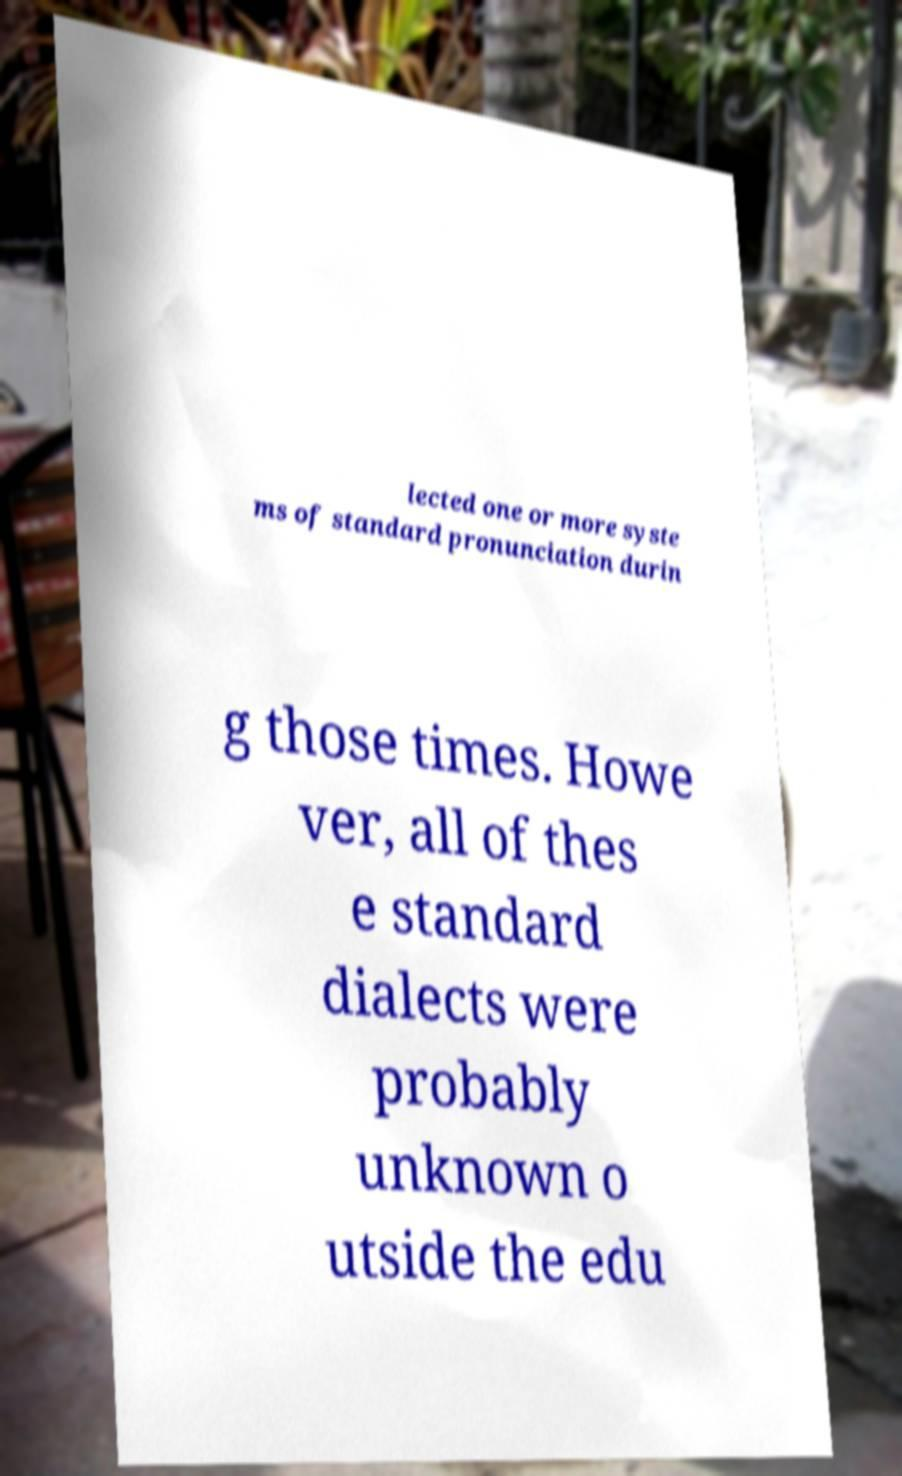Please identify and transcribe the text found in this image. lected one or more syste ms of standard pronunciation durin g those times. Howe ver, all of thes e standard dialects were probably unknown o utside the edu 